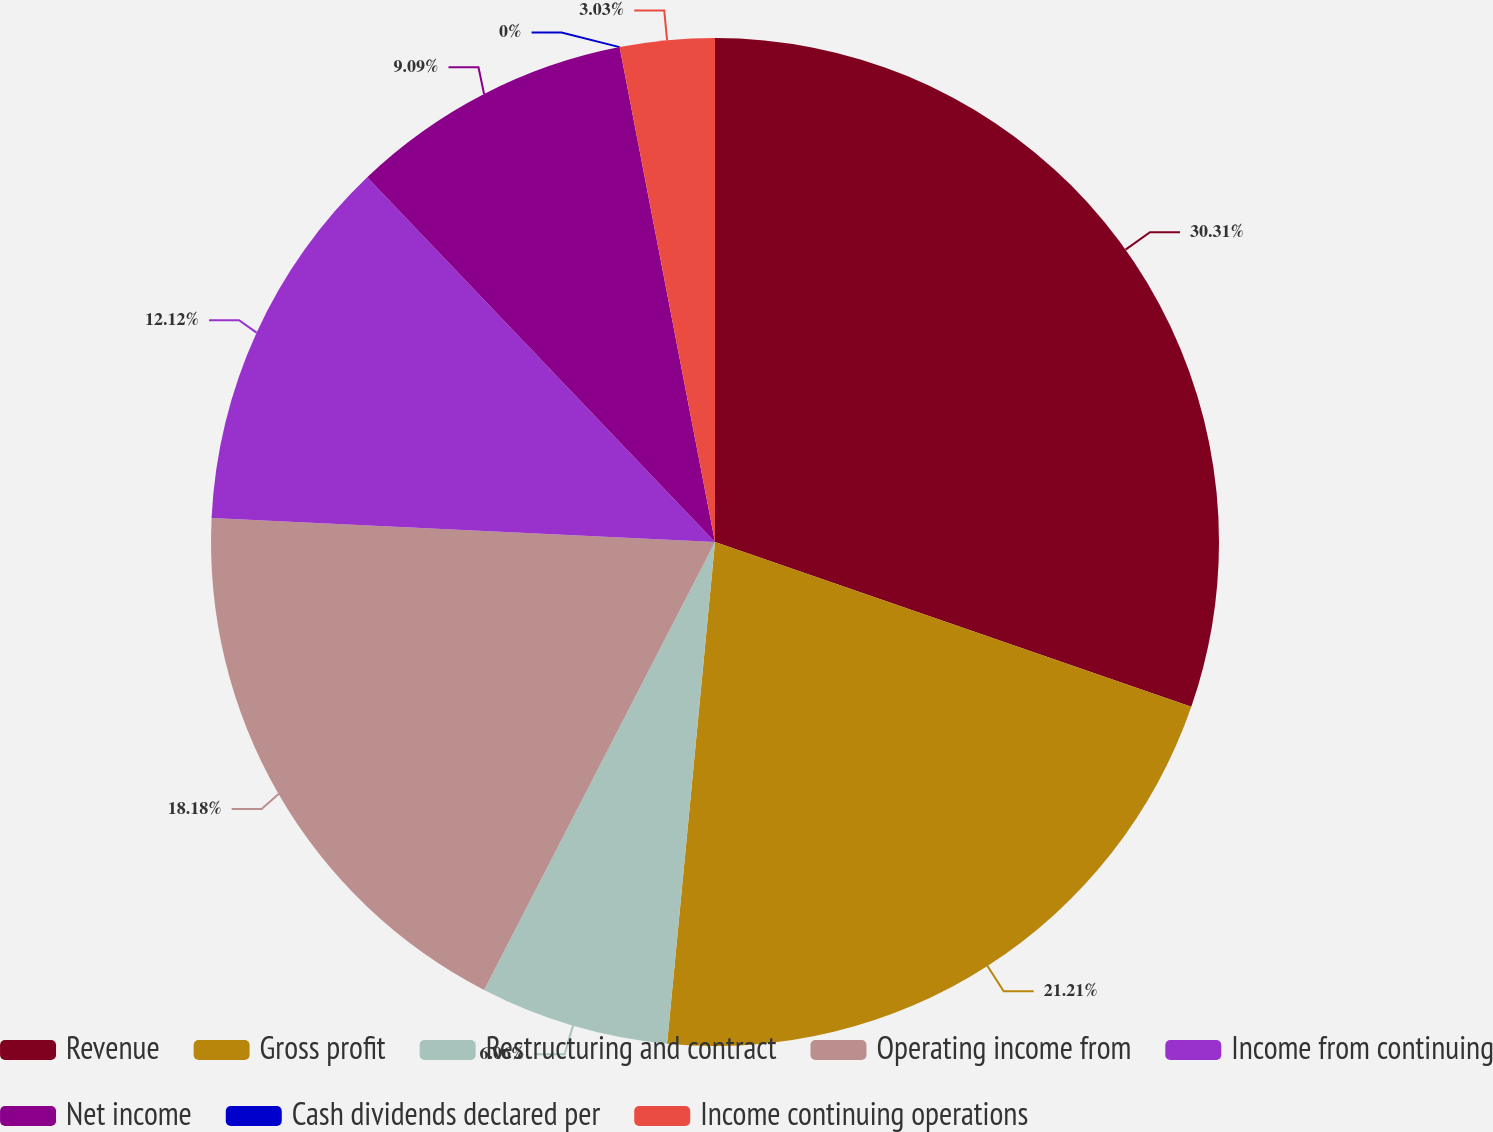Convert chart to OTSL. <chart><loc_0><loc_0><loc_500><loc_500><pie_chart><fcel>Revenue<fcel>Gross profit<fcel>Restructuring and contract<fcel>Operating income from<fcel>Income from continuing<fcel>Net income<fcel>Cash dividends declared per<fcel>Income continuing operations<nl><fcel>30.3%<fcel>21.21%<fcel>6.06%<fcel>18.18%<fcel>12.12%<fcel>9.09%<fcel>0.0%<fcel>3.03%<nl></chart> 